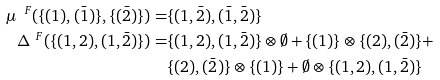<formula> <loc_0><loc_0><loc_500><loc_500>\mu ^ { \ F } ( \{ ( 1 ) , ( \bar { 1 } ) \} , \{ ( \bar { 2 } ) \} ) = & \{ ( 1 , \bar { 2 } ) , ( \bar { 1 } , \bar { 2 } ) \} \\ \Delta ^ { \ F } ( \{ ( 1 , 2 ) , ( 1 , \bar { 2 } ) \} ) = & \{ ( 1 , 2 ) , ( 1 , \bar { 2 } ) \} \otimes \emptyset + \{ ( 1 ) \} \otimes \{ ( 2 ) , ( \bar { 2 } ) \} + \\ & \{ ( 2 ) , ( \bar { 2 } ) \} \otimes \{ ( 1 ) \} + \emptyset \otimes \{ ( 1 , 2 ) , ( 1 , \bar { 2 } ) \}</formula> 